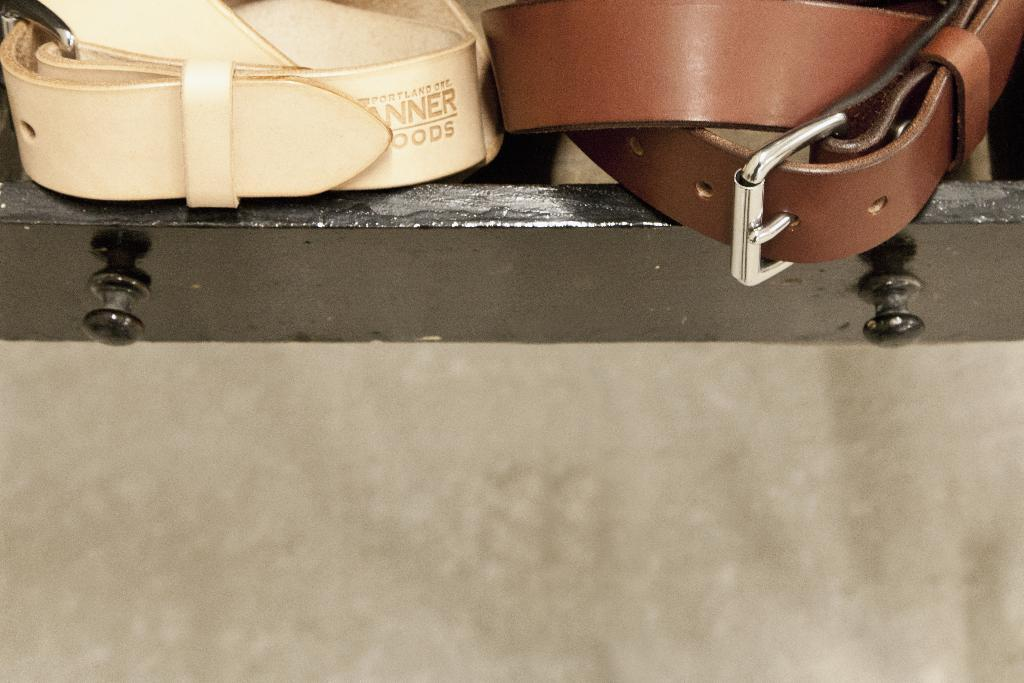How many belts are visible in the image? There are two belts in the image. What type of object is underneath the belts? There is an iron object in the image, and it is underneath the belts. What type of slip can be seen on the iron object in the image? There is no slip present on the iron object in the image. What type of dinner is being prepared on the iron object in the image? There is no dinner being prepared on the iron object in the image. 